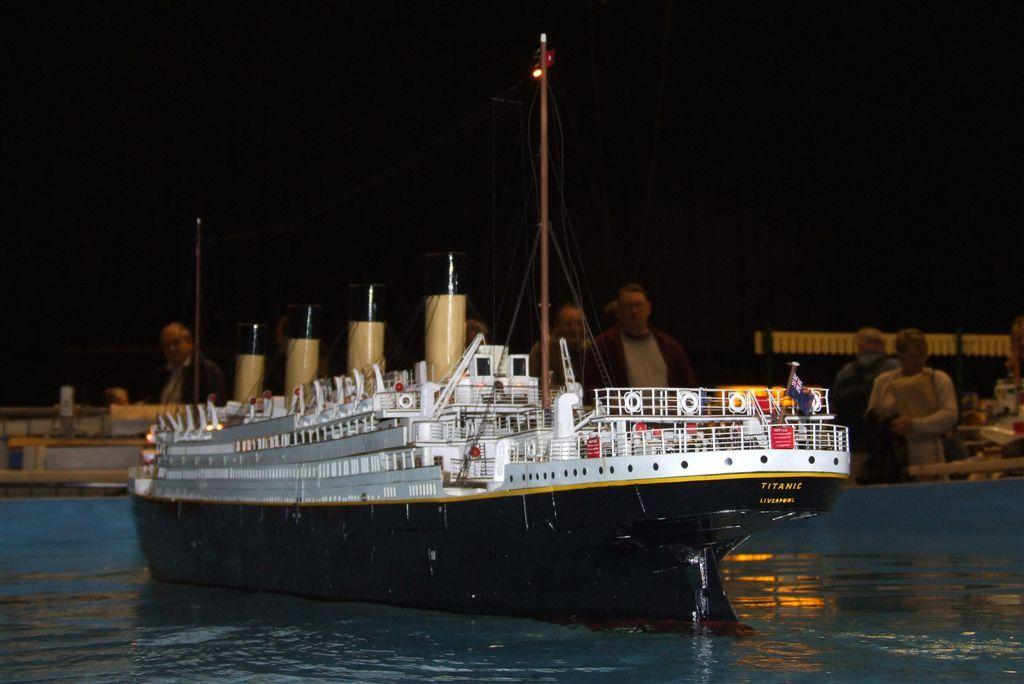What is the main subject of the image? There is a ship in the image. Where is the ship located? The ship is on the water. Can you describe the background of the image? The background color is black, and there are people visible in the background. What type of bit is being used by the ship in the image? There is no bit present in the image, as ships are not typically associated with bits. 